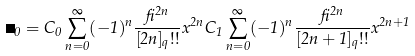Convert formula to latex. <formula><loc_0><loc_0><loc_500><loc_500>\psi _ { 0 } = C _ { 0 } \sum _ { n = 0 } ^ { \infty } ( - 1 ) ^ { n } \frac { \beta ^ { 2 n } } { [ 2 n ] _ { q } ! ! } x ^ { 2 n } C _ { 1 } \sum _ { n = 0 } ^ { \infty } ( - 1 ) ^ { n } \frac { \beta ^ { 2 n } } { [ 2 n + 1 ] _ { q } ! ! } x ^ { 2 n + 1 }</formula> 